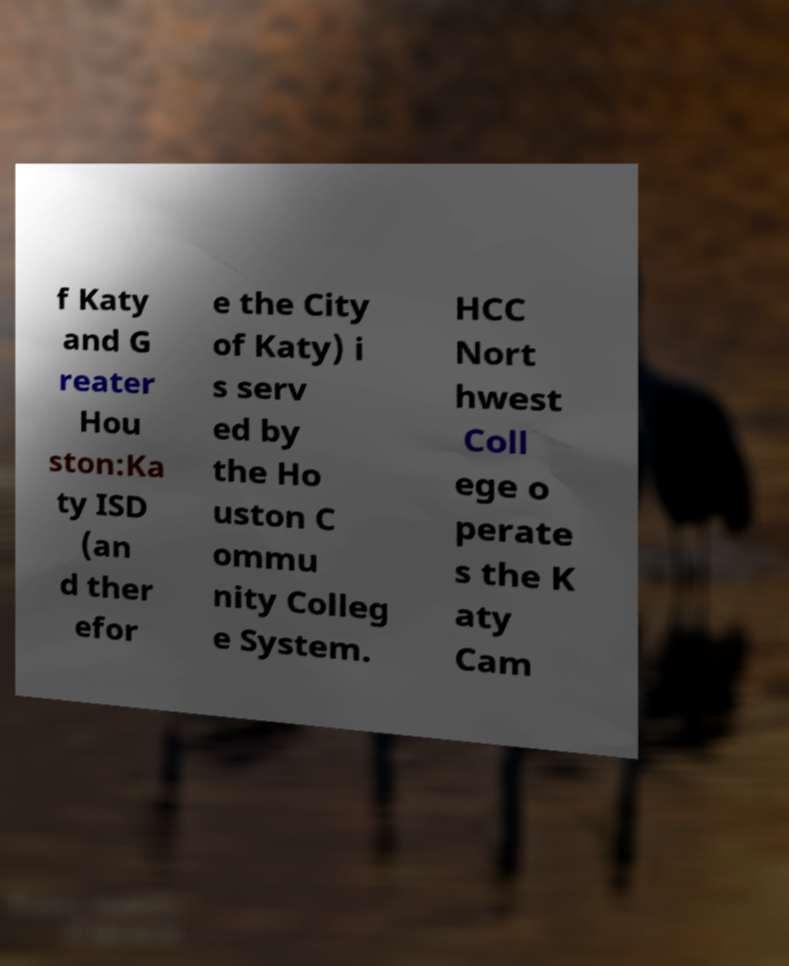I need the written content from this picture converted into text. Can you do that? f Katy and G reater Hou ston:Ka ty ISD (an d ther efor e the City of Katy) i s serv ed by the Ho uston C ommu nity Colleg e System. HCC Nort hwest Coll ege o perate s the K aty Cam 